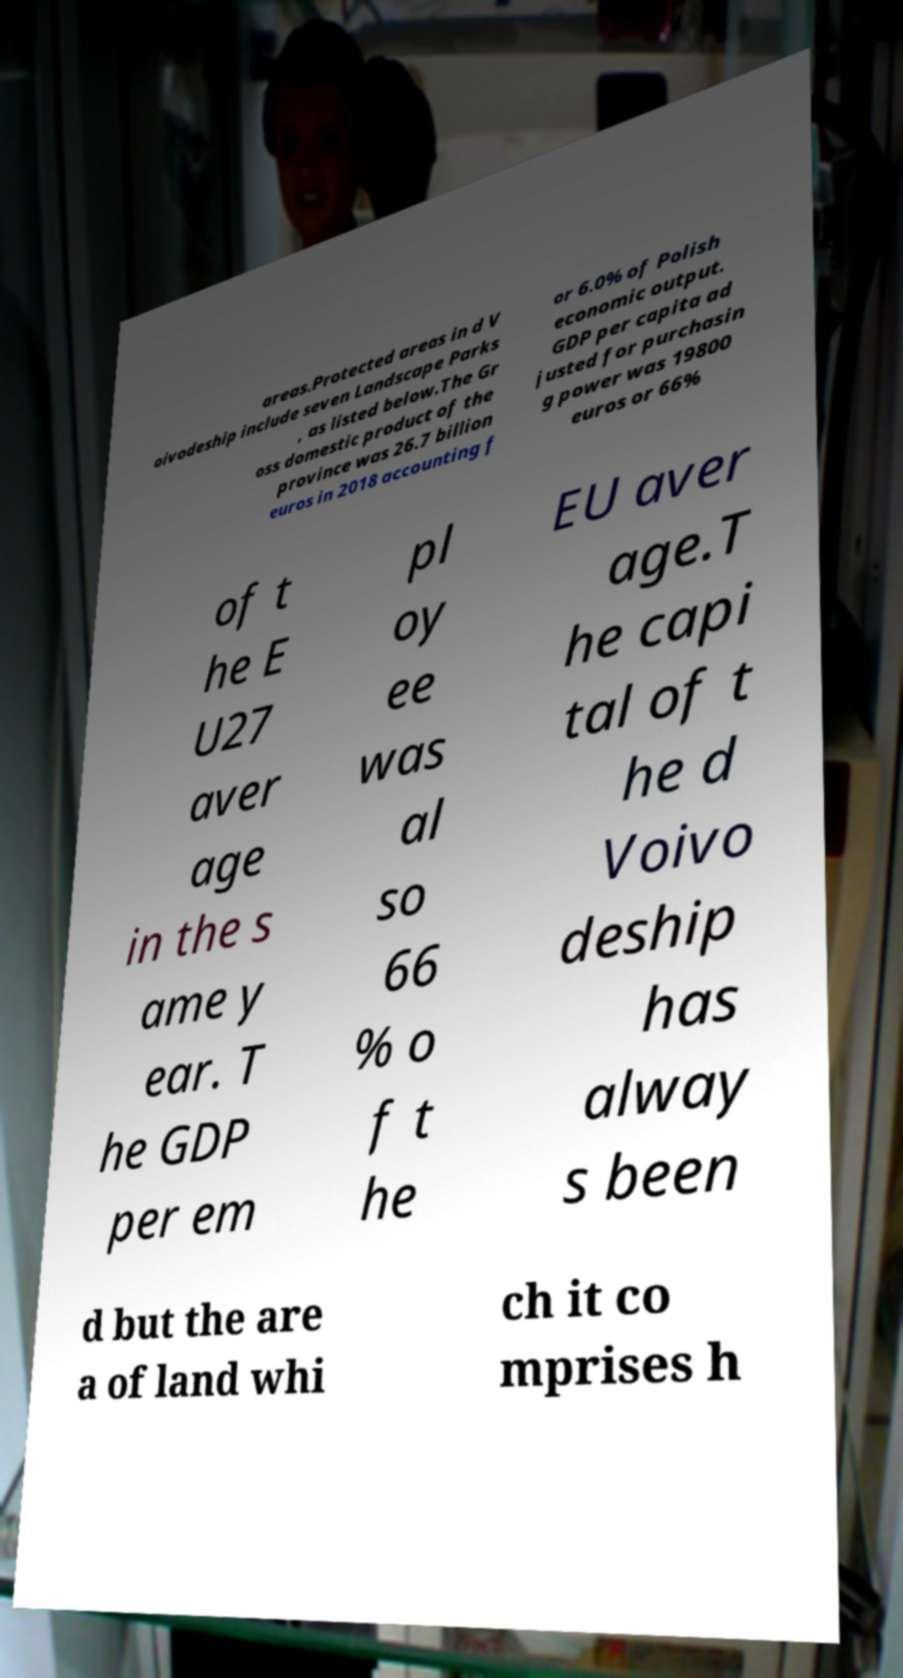Could you extract and type out the text from this image? areas.Protected areas in d V oivodeship include seven Landscape Parks , as listed below.The Gr oss domestic product of the province was 26.7 billion euros in 2018 accounting f or 6.0% of Polish economic output. GDP per capita ad justed for purchasin g power was 19800 euros or 66% of t he E U27 aver age in the s ame y ear. T he GDP per em pl oy ee was al so 66 % o f t he EU aver age.T he capi tal of t he d Voivo deship has alway s been d but the are a of land whi ch it co mprises h 